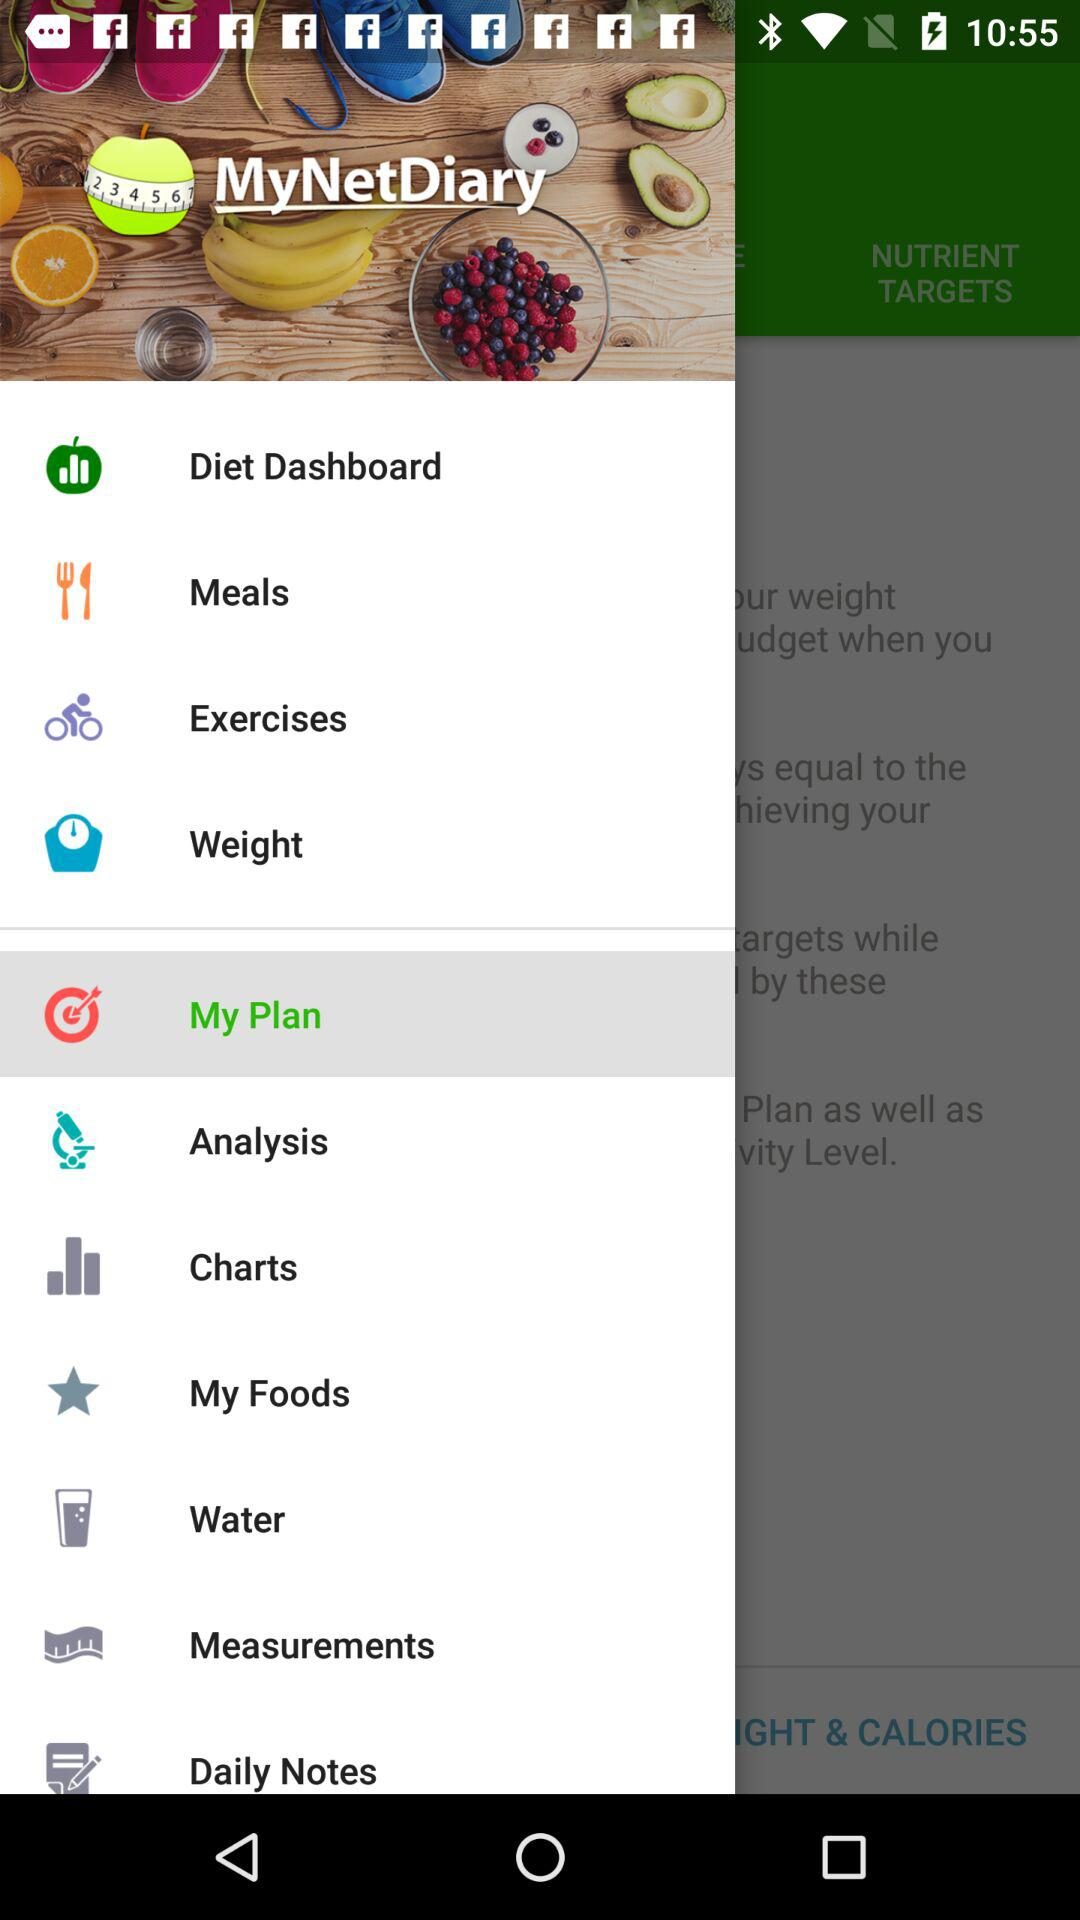What is the app name? The app name is "MyNetDiary". 